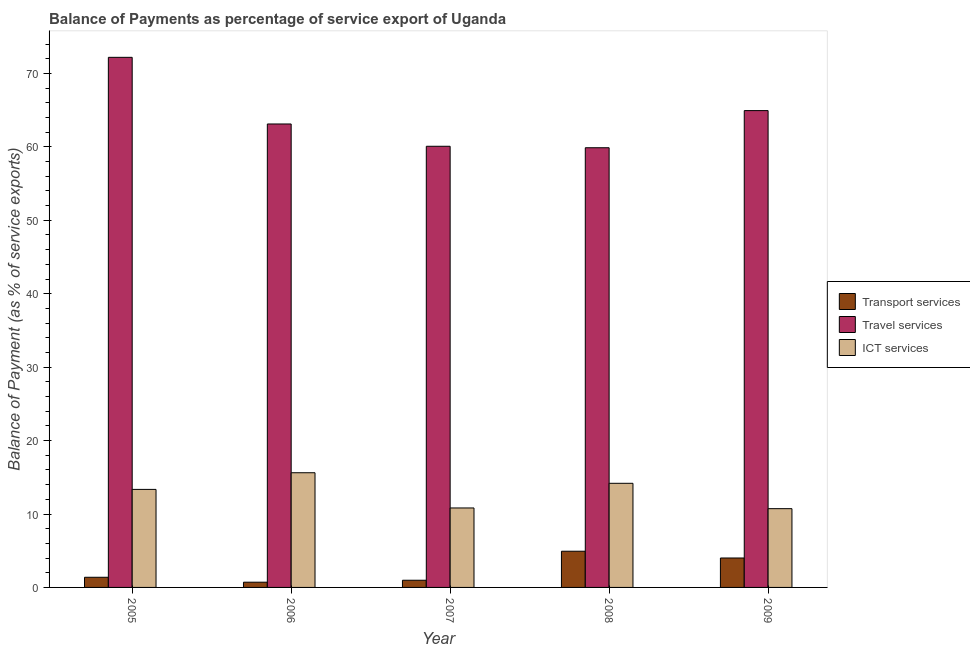How many different coloured bars are there?
Offer a very short reply. 3. How many groups of bars are there?
Your response must be concise. 5. Are the number of bars per tick equal to the number of legend labels?
Keep it short and to the point. Yes. Are the number of bars on each tick of the X-axis equal?
Your answer should be compact. Yes. How many bars are there on the 1st tick from the left?
Provide a short and direct response. 3. What is the label of the 5th group of bars from the left?
Provide a short and direct response. 2009. What is the balance of payment of ict services in 2005?
Your response must be concise. 13.35. Across all years, what is the maximum balance of payment of travel services?
Give a very brief answer. 72.2. Across all years, what is the minimum balance of payment of transport services?
Your response must be concise. 0.71. What is the total balance of payment of transport services in the graph?
Your answer should be compact. 12.01. What is the difference between the balance of payment of travel services in 2007 and that in 2009?
Make the answer very short. -4.86. What is the difference between the balance of payment of travel services in 2008 and the balance of payment of ict services in 2009?
Ensure brevity in your answer.  -5.06. What is the average balance of payment of transport services per year?
Keep it short and to the point. 2.4. In the year 2005, what is the difference between the balance of payment of ict services and balance of payment of travel services?
Give a very brief answer. 0. What is the ratio of the balance of payment of travel services in 2005 to that in 2009?
Your answer should be very brief. 1.11. Is the difference between the balance of payment of travel services in 2006 and 2008 greater than the difference between the balance of payment of ict services in 2006 and 2008?
Provide a succinct answer. No. What is the difference between the highest and the second highest balance of payment of transport services?
Keep it short and to the point. 0.92. What is the difference between the highest and the lowest balance of payment of transport services?
Make the answer very short. 4.22. Is the sum of the balance of payment of transport services in 2005 and 2006 greater than the maximum balance of payment of ict services across all years?
Your answer should be very brief. No. What does the 2nd bar from the left in 2009 represents?
Give a very brief answer. Travel services. What does the 1st bar from the right in 2008 represents?
Offer a very short reply. ICT services. Are all the bars in the graph horizontal?
Provide a short and direct response. No. How many legend labels are there?
Provide a succinct answer. 3. What is the title of the graph?
Give a very brief answer. Balance of Payments as percentage of service export of Uganda. What is the label or title of the X-axis?
Provide a short and direct response. Year. What is the label or title of the Y-axis?
Offer a terse response. Balance of Payment (as % of service exports). What is the Balance of Payment (as % of service exports) of Transport services in 2005?
Offer a very short reply. 1.38. What is the Balance of Payment (as % of service exports) of Travel services in 2005?
Provide a short and direct response. 72.2. What is the Balance of Payment (as % of service exports) of ICT services in 2005?
Offer a terse response. 13.35. What is the Balance of Payment (as % of service exports) in Transport services in 2006?
Keep it short and to the point. 0.71. What is the Balance of Payment (as % of service exports) in Travel services in 2006?
Your answer should be compact. 63.12. What is the Balance of Payment (as % of service exports) of ICT services in 2006?
Give a very brief answer. 15.62. What is the Balance of Payment (as % of service exports) of Transport services in 2007?
Give a very brief answer. 0.98. What is the Balance of Payment (as % of service exports) of Travel services in 2007?
Your answer should be very brief. 60.08. What is the Balance of Payment (as % of service exports) in ICT services in 2007?
Keep it short and to the point. 10.82. What is the Balance of Payment (as % of service exports) in Transport services in 2008?
Your response must be concise. 4.93. What is the Balance of Payment (as % of service exports) of Travel services in 2008?
Provide a succinct answer. 59.88. What is the Balance of Payment (as % of service exports) of ICT services in 2008?
Your answer should be very brief. 14.18. What is the Balance of Payment (as % of service exports) of Transport services in 2009?
Your response must be concise. 4.01. What is the Balance of Payment (as % of service exports) of Travel services in 2009?
Keep it short and to the point. 64.94. What is the Balance of Payment (as % of service exports) of ICT services in 2009?
Give a very brief answer. 10.73. Across all years, what is the maximum Balance of Payment (as % of service exports) in Transport services?
Your answer should be compact. 4.93. Across all years, what is the maximum Balance of Payment (as % of service exports) of Travel services?
Provide a succinct answer. 72.2. Across all years, what is the maximum Balance of Payment (as % of service exports) of ICT services?
Offer a very short reply. 15.62. Across all years, what is the minimum Balance of Payment (as % of service exports) in Transport services?
Offer a very short reply. 0.71. Across all years, what is the minimum Balance of Payment (as % of service exports) of Travel services?
Offer a terse response. 59.88. Across all years, what is the minimum Balance of Payment (as % of service exports) of ICT services?
Keep it short and to the point. 10.73. What is the total Balance of Payment (as % of service exports) of Transport services in the graph?
Your response must be concise. 12.01. What is the total Balance of Payment (as % of service exports) of Travel services in the graph?
Provide a short and direct response. 320.22. What is the total Balance of Payment (as % of service exports) of ICT services in the graph?
Give a very brief answer. 64.7. What is the difference between the Balance of Payment (as % of service exports) of Transport services in 2005 and that in 2006?
Keep it short and to the point. 0.67. What is the difference between the Balance of Payment (as % of service exports) of Travel services in 2005 and that in 2006?
Provide a succinct answer. 9.08. What is the difference between the Balance of Payment (as % of service exports) in ICT services in 2005 and that in 2006?
Your answer should be very brief. -2.27. What is the difference between the Balance of Payment (as % of service exports) of Transport services in 2005 and that in 2007?
Offer a very short reply. 0.4. What is the difference between the Balance of Payment (as % of service exports) in Travel services in 2005 and that in 2007?
Offer a terse response. 12.11. What is the difference between the Balance of Payment (as % of service exports) of ICT services in 2005 and that in 2007?
Ensure brevity in your answer.  2.53. What is the difference between the Balance of Payment (as % of service exports) in Transport services in 2005 and that in 2008?
Give a very brief answer. -3.55. What is the difference between the Balance of Payment (as % of service exports) in Travel services in 2005 and that in 2008?
Make the answer very short. 12.31. What is the difference between the Balance of Payment (as % of service exports) of ICT services in 2005 and that in 2008?
Offer a very short reply. -0.83. What is the difference between the Balance of Payment (as % of service exports) in Transport services in 2005 and that in 2009?
Offer a very short reply. -2.63. What is the difference between the Balance of Payment (as % of service exports) in Travel services in 2005 and that in 2009?
Offer a terse response. 7.25. What is the difference between the Balance of Payment (as % of service exports) of ICT services in 2005 and that in 2009?
Offer a terse response. 2.62. What is the difference between the Balance of Payment (as % of service exports) of Transport services in 2006 and that in 2007?
Offer a terse response. -0.27. What is the difference between the Balance of Payment (as % of service exports) in Travel services in 2006 and that in 2007?
Provide a succinct answer. 3.04. What is the difference between the Balance of Payment (as % of service exports) in ICT services in 2006 and that in 2007?
Give a very brief answer. 4.8. What is the difference between the Balance of Payment (as % of service exports) of Transport services in 2006 and that in 2008?
Provide a short and direct response. -4.22. What is the difference between the Balance of Payment (as % of service exports) of Travel services in 2006 and that in 2008?
Your answer should be very brief. 3.24. What is the difference between the Balance of Payment (as % of service exports) in ICT services in 2006 and that in 2008?
Your answer should be compact. 1.44. What is the difference between the Balance of Payment (as % of service exports) of Transport services in 2006 and that in 2009?
Offer a very short reply. -3.3. What is the difference between the Balance of Payment (as % of service exports) in Travel services in 2006 and that in 2009?
Offer a terse response. -1.82. What is the difference between the Balance of Payment (as % of service exports) of ICT services in 2006 and that in 2009?
Keep it short and to the point. 4.89. What is the difference between the Balance of Payment (as % of service exports) of Transport services in 2007 and that in 2008?
Your answer should be compact. -3.95. What is the difference between the Balance of Payment (as % of service exports) in Travel services in 2007 and that in 2008?
Provide a short and direct response. 0.2. What is the difference between the Balance of Payment (as % of service exports) in ICT services in 2007 and that in 2008?
Provide a short and direct response. -3.36. What is the difference between the Balance of Payment (as % of service exports) in Transport services in 2007 and that in 2009?
Offer a very short reply. -3.03. What is the difference between the Balance of Payment (as % of service exports) in Travel services in 2007 and that in 2009?
Offer a very short reply. -4.86. What is the difference between the Balance of Payment (as % of service exports) in ICT services in 2007 and that in 2009?
Your answer should be very brief. 0.1. What is the difference between the Balance of Payment (as % of service exports) in Transport services in 2008 and that in 2009?
Offer a very short reply. 0.92. What is the difference between the Balance of Payment (as % of service exports) of Travel services in 2008 and that in 2009?
Make the answer very short. -5.06. What is the difference between the Balance of Payment (as % of service exports) in ICT services in 2008 and that in 2009?
Provide a succinct answer. 3.45. What is the difference between the Balance of Payment (as % of service exports) in Transport services in 2005 and the Balance of Payment (as % of service exports) in Travel services in 2006?
Provide a short and direct response. -61.74. What is the difference between the Balance of Payment (as % of service exports) in Transport services in 2005 and the Balance of Payment (as % of service exports) in ICT services in 2006?
Your answer should be very brief. -14.24. What is the difference between the Balance of Payment (as % of service exports) in Travel services in 2005 and the Balance of Payment (as % of service exports) in ICT services in 2006?
Ensure brevity in your answer.  56.58. What is the difference between the Balance of Payment (as % of service exports) of Transport services in 2005 and the Balance of Payment (as % of service exports) of Travel services in 2007?
Offer a terse response. -58.7. What is the difference between the Balance of Payment (as % of service exports) in Transport services in 2005 and the Balance of Payment (as % of service exports) in ICT services in 2007?
Provide a short and direct response. -9.44. What is the difference between the Balance of Payment (as % of service exports) in Travel services in 2005 and the Balance of Payment (as % of service exports) in ICT services in 2007?
Your answer should be very brief. 61.37. What is the difference between the Balance of Payment (as % of service exports) of Transport services in 2005 and the Balance of Payment (as % of service exports) of Travel services in 2008?
Make the answer very short. -58.5. What is the difference between the Balance of Payment (as % of service exports) in Transport services in 2005 and the Balance of Payment (as % of service exports) in ICT services in 2008?
Provide a succinct answer. -12.8. What is the difference between the Balance of Payment (as % of service exports) in Travel services in 2005 and the Balance of Payment (as % of service exports) in ICT services in 2008?
Your answer should be compact. 58.01. What is the difference between the Balance of Payment (as % of service exports) of Transport services in 2005 and the Balance of Payment (as % of service exports) of Travel services in 2009?
Your response must be concise. -63.56. What is the difference between the Balance of Payment (as % of service exports) in Transport services in 2005 and the Balance of Payment (as % of service exports) in ICT services in 2009?
Your answer should be very brief. -9.34. What is the difference between the Balance of Payment (as % of service exports) of Travel services in 2005 and the Balance of Payment (as % of service exports) of ICT services in 2009?
Your answer should be compact. 61.47. What is the difference between the Balance of Payment (as % of service exports) of Transport services in 2006 and the Balance of Payment (as % of service exports) of Travel services in 2007?
Offer a terse response. -59.37. What is the difference between the Balance of Payment (as % of service exports) of Transport services in 2006 and the Balance of Payment (as % of service exports) of ICT services in 2007?
Provide a short and direct response. -10.11. What is the difference between the Balance of Payment (as % of service exports) in Travel services in 2006 and the Balance of Payment (as % of service exports) in ICT services in 2007?
Your response must be concise. 52.29. What is the difference between the Balance of Payment (as % of service exports) in Transport services in 2006 and the Balance of Payment (as % of service exports) in Travel services in 2008?
Provide a succinct answer. -59.17. What is the difference between the Balance of Payment (as % of service exports) of Transport services in 2006 and the Balance of Payment (as % of service exports) of ICT services in 2008?
Offer a terse response. -13.47. What is the difference between the Balance of Payment (as % of service exports) of Travel services in 2006 and the Balance of Payment (as % of service exports) of ICT services in 2008?
Provide a succinct answer. 48.94. What is the difference between the Balance of Payment (as % of service exports) of Transport services in 2006 and the Balance of Payment (as % of service exports) of Travel services in 2009?
Give a very brief answer. -64.23. What is the difference between the Balance of Payment (as % of service exports) of Transport services in 2006 and the Balance of Payment (as % of service exports) of ICT services in 2009?
Your response must be concise. -10.01. What is the difference between the Balance of Payment (as % of service exports) in Travel services in 2006 and the Balance of Payment (as % of service exports) in ICT services in 2009?
Provide a short and direct response. 52.39. What is the difference between the Balance of Payment (as % of service exports) of Transport services in 2007 and the Balance of Payment (as % of service exports) of Travel services in 2008?
Your answer should be compact. -58.9. What is the difference between the Balance of Payment (as % of service exports) of Transport services in 2007 and the Balance of Payment (as % of service exports) of ICT services in 2008?
Keep it short and to the point. -13.2. What is the difference between the Balance of Payment (as % of service exports) of Travel services in 2007 and the Balance of Payment (as % of service exports) of ICT services in 2008?
Ensure brevity in your answer.  45.9. What is the difference between the Balance of Payment (as % of service exports) of Transport services in 2007 and the Balance of Payment (as % of service exports) of Travel services in 2009?
Ensure brevity in your answer.  -63.96. What is the difference between the Balance of Payment (as % of service exports) in Transport services in 2007 and the Balance of Payment (as % of service exports) in ICT services in 2009?
Offer a terse response. -9.75. What is the difference between the Balance of Payment (as % of service exports) in Travel services in 2007 and the Balance of Payment (as % of service exports) in ICT services in 2009?
Provide a short and direct response. 49.35. What is the difference between the Balance of Payment (as % of service exports) of Transport services in 2008 and the Balance of Payment (as % of service exports) of Travel services in 2009?
Your response must be concise. -60.01. What is the difference between the Balance of Payment (as % of service exports) in Transport services in 2008 and the Balance of Payment (as % of service exports) in ICT services in 2009?
Keep it short and to the point. -5.8. What is the difference between the Balance of Payment (as % of service exports) of Travel services in 2008 and the Balance of Payment (as % of service exports) of ICT services in 2009?
Provide a short and direct response. 49.16. What is the average Balance of Payment (as % of service exports) in Transport services per year?
Provide a succinct answer. 2.4. What is the average Balance of Payment (as % of service exports) in Travel services per year?
Your answer should be very brief. 64.04. What is the average Balance of Payment (as % of service exports) in ICT services per year?
Make the answer very short. 12.94. In the year 2005, what is the difference between the Balance of Payment (as % of service exports) of Transport services and Balance of Payment (as % of service exports) of Travel services?
Your answer should be compact. -70.81. In the year 2005, what is the difference between the Balance of Payment (as % of service exports) in Transport services and Balance of Payment (as % of service exports) in ICT services?
Keep it short and to the point. -11.97. In the year 2005, what is the difference between the Balance of Payment (as % of service exports) in Travel services and Balance of Payment (as % of service exports) in ICT services?
Provide a short and direct response. 58.84. In the year 2006, what is the difference between the Balance of Payment (as % of service exports) in Transport services and Balance of Payment (as % of service exports) in Travel services?
Make the answer very short. -62.41. In the year 2006, what is the difference between the Balance of Payment (as % of service exports) of Transport services and Balance of Payment (as % of service exports) of ICT services?
Your response must be concise. -14.91. In the year 2006, what is the difference between the Balance of Payment (as % of service exports) of Travel services and Balance of Payment (as % of service exports) of ICT services?
Ensure brevity in your answer.  47.5. In the year 2007, what is the difference between the Balance of Payment (as % of service exports) in Transport services and Balance of Payment (as % of service exports) in Travel services?
Provide a short and direct response. -59.1. In the year 2007, what is the difference between the Balance of Payment (as % of service exports) in Transport services and Balance of Payment (as % of service exports) in ICT services?
Offer a terse response. -9.84. In the year 2007, what is the difference between the Balance of Payment (as % of service exports) of Travel services and Balance of Payment (as % of service exports) of ICT services?
Provide a succinct answer. 49.26. In the year 2008, what is the difference between the Balance of Payment (as % of service exports) of Transport services and Balance of Payment (as % of service exports) of Travel services?
Give a very brief answer. -54.95. In the year 2008, what is the difference between the Balance of Payment (as % of service exports) in Transport services and Balance of Payment (as % of service exports) in ICT services?
Keep it short and to the point. -9.25. In the year 2008, what is the difference between the Balance of Payment (as % of service exports) in Travel services and Balance of Payment (as % of service exports) in ICT services?
Ensure brevity in your answer.  45.7. In the year 2009, what is the difference between the Balance of Payment (as % of service exports) of Transport services and Balance of Payment (as % of service exports) of Travel services?
Provide a short and direct response. -60.93. In the year 2009, what is the difference between the Balance of Payment (as % of service exports) in Transport services and Balance of Payment (as % of service exports) in ICT services?
Your answer should be compact. -6.72. In the year 2009, what is the difference between the Balance of Payment (as % of service exports) of Travel services and Balance of Payment (as % of service exports) of ICT services?
Offer a very short reply. 54.21. What is the ratio of the Balance of Payment (as % of service exports) of Transport services in 2005 to that in 2006?
Offer a terse response. 1.94. What is the ratio of the Balance of Payment (as % of service exports) in Travel services in 2005 to that in 2006?
Keep it short and to the point. 1.14. What is the ratio of the Balance of Payment (as % of service exports) of ICT services in 2005 to that in 2006?
Offer a terse response. 0.85. What is the ratio of the Balance of Payment (as % of service exports) of Transport services in 2005 to that in 2007?
Ensure brevity in your answer.  1.41. What is the ratio of the Balance of Payment (as % of service exports) of Travel services in 2005 to that in 2007?
Your response must be concise. 1.2. What is the ratio of the Balance of Payment (as % of service exports) in ICT services in 2005 to that in 2007?
Your response must be concise. 1.23. What is the ratio of the Balance of Payment (as % of service exports) in Transport services in 2005 to that in 2008?
Offer a terse response. 0.28. What is the ratio of the Balance of Payment (as % of service exports) of Travel services in 2005 to that in 2008?
Your answer should be very brief. 1.21. What is the ratio of the Balance of Payment (as % of service exports) in ICT services in 2005 to that in 2008?
Make the answer very short. 0.94. What is the ratio of the Balance of Payment (as % of service exports) in Transport services in 2005 to that in 2009?
Keep it short and to the point. 0.34. What is the ratio of the Balance of Payment (as % of service exports) in Travel services in 2005 to that in 2009?
Your answer should be very brief. 1.11. What is the ratio of the Balance of Payment (as % of service exports) in ICT services in 2005 to that in 2009?
Your response must be concise. 1.24. What is the ratio of the Balance of Payment (as % of service exports) of Transport services in 2006 to that in 2007?
Your answer should be very brief. 0.73. What is the ratio of the Balance of Payment (as % of service exports) in Travel services in 2006 to that in 2007?
Keep it short and to the point. 1.05. What is the ratio of the Balance of Payment (as % of service exports) of ICT services in 2006 to that in 2007?
Provide a succinct answer. 1.44. What is the ratio of the Balance of Payment (as % of service exports) of Transport services in 2006 to that in 2008?
Give a very brief answer. 0.14. What is the ratio of the Balance of Payment (as % of service exports) in Travel services in 2006 to that in 2008?
Provide a short and direct response. 1.05. What is the ratio of the Balance of Payment (as % of service exports) in ICT services in 2006 to that in 2008?
Your response must be concise. 1.1. What is the ratio of the Balance of Payment (as % of service exports) of Transport services in 2006 to that in 2009?
Ensure brevity in your answer.  0.18. What is the ratio of the Balance of Payment (as % of service exports) of Travel services in 2006 to that in 2009?
Give a very brief answer. 0.97. What is the ratio of the Balance of Payment (as % of service exports) of ICT services in 2006 to that in 2009?
Give a very brief answer. 1.46. What is the ratio of the Balance of Payment (as % of service exports) in Transport services in 2007 to that in 2008?
Your answer should be compact. 0.2. What is the ratio of the Balance of Payment (as % of service exports) of ICT services in 2007 to that in 2008?
Provide a short and direct response. 0.76. What is the ratio of the Balance of Payment (as % of service exports) in Transport services in 2007 to that in 2009?
Provide a succinct answer. 0.24. What is the ratio of the Balance of Payment (as % of service exports) in Travel services in 2007 to that in 2009?
Offer a terse response. 0.93. What is the ratio of the Balance of Payment (as % of service exports) in ICT services in 2007 to that in 2009?
Offer a terse response. 1.01. What is the ratio of the Balance of Payment (as % of service exports) in Transport services in 2008 to that in 2009?
Offer a terse response. 1.23. What is the ratio of the Balance of Payment (as % of service exports) of Travel services in 2008 to that in 2009?
Offer a terse response. 0.92. What is the ratio of the Balance of Payment (as % of service exports) in ICT services in 2008 to that in 2009?
Your answer should be very brief. 1.32. What is the difference between the highest and the second highest Balance of Payment (as % of service exports) in Transport services?
Provide a short and direct response. 0.92. What is the difference between the highest and the second highest Balance of Payment (as % of service exports) of Travel services?
Give a very brief answer. 7.25. What is the difference between the highest and the second highest Balance of Payment (as % of service exports) of ICT services?
Your response must be concise. 1.44. What is the difference between the highest and the lowest Balance of Payment (as % of service exports) of Transport services?
Your response must be concise. 4.22. What is the difference between the highest and the lowest Balance of Payment (as % of service exports) in Travel services?
Ensure brevity in your answer.  12.31. What is the difference between the highest and the lowest Balance of Payment (as % of service exports) in ICT services?
Your response must be concise. 4.89. 